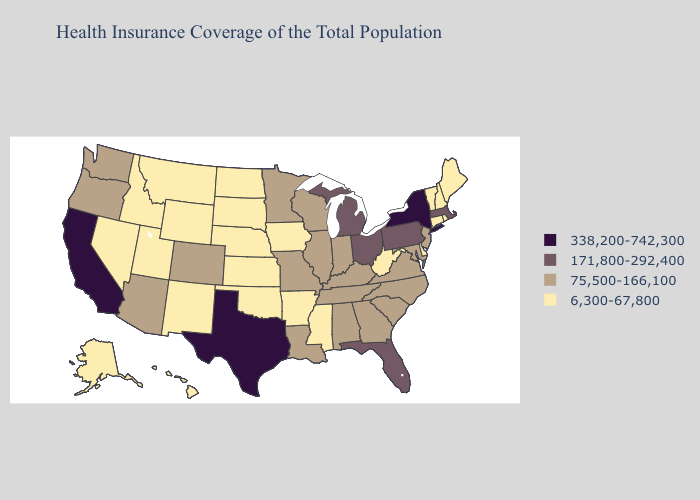Which states have the lowest value in the Northeast?
Short answer required. Connecticut, Maine, New Hampshire, Rhode Island, Vermont. Does Tennessee have the lowest value in the South?
Answer briefly. No. Which states have the lowest value in the USA?
Write a very short answer. Alaska, Arkansas, Connecticut, Delaware, Hawaii, Idaho, Iowa, Kansas, Maine, Mississippi, Montana, Nebraska, Nevada, New Hampshire, New Mexico, North Dakota, Oklahoma, Rhode Island, South Dakota, Utah, Vermont, West Virginia, Wyoming. Name the states that have a value in the range 171,800-292,400?
Give a very brief answer. Florida, Massachusetts, Michigan, Ohio, Pennsylvania. Name the states that have a value in the range 75,500-166,100?
Short answer required. Alabama, Arizona, Colorado, Georgia, Illinois, Indiana, Kentucky, Louisiana, Maryland, Minnesota, Missouri, New Jersey, North Carolina, Oregon, South Carolina, Tennessee, Virginia, Washington, Wisconsin. What is the value of Idaho?
Short answer required. 6,300-67,800. What is the value of Missouri?
Be succinct. 75,500-166,100. What is the value of Maine?
Give a very brief answer. 6,300-67,800. Name the states that have a value in the range 6,300-67,800?
Give a very brief answer. Alaska, Arkansas, Connecticut, Delaware, Hawaii, Idaho, Iowa, Kansas, Maine, Mississippi, Montana, Nebraska, Nevada, New Hampshire, New Mexico, North Dakota, Oklahoma, Rhode Island, South Dakota, Utah, Vermont, West Virginia, Wyoming. Does New York have the same value as Texas?
Concise answer only. Yes. Name the states that have a value in the range 338,200-742,300?
Concise answer only. California, New York, Texas. Which states hav the highest value in the MidWest?
Quick response, please. Michigan, Ohio. What is the value of New Jersey?
Quick response, please. 75,500-166,100. What is the value of South Dakota?
Quick response, please. 6,300-67,800. What is the value of Indiana?
Give a very brief answer. 75,500-166,100. 